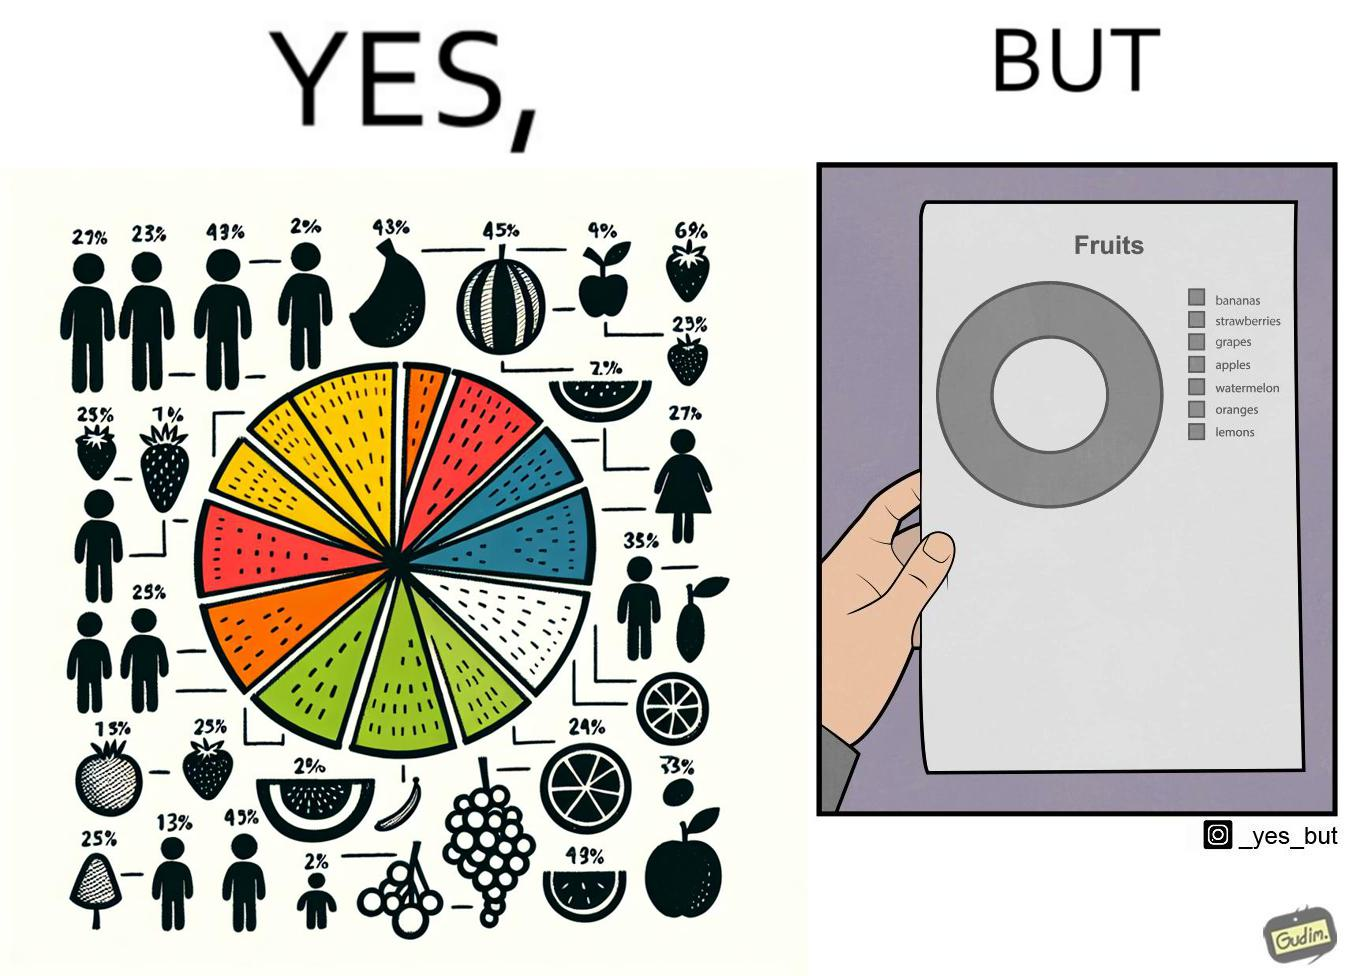Does this image contain satire or humor? Yes, this image is satirical. 